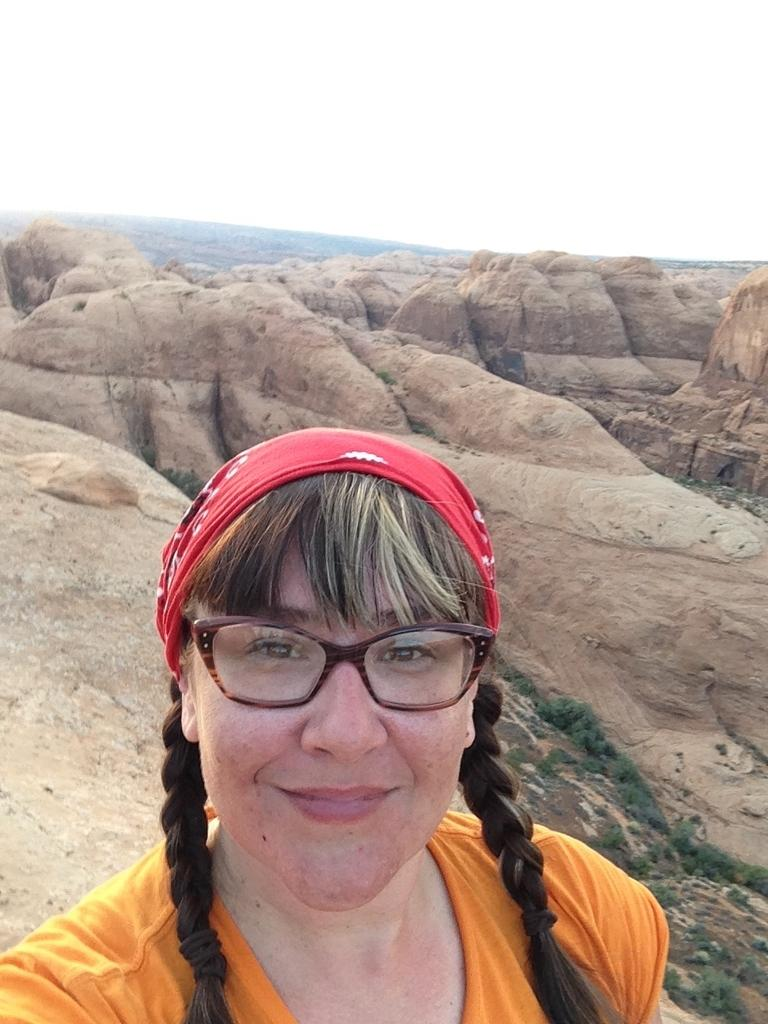Who is present in the image? There is a woman in the image. What is the woman wearing in the image? The woman is wearing spectacles in the image. What type of natural elements can be seen in the image? Rocks are visible in the image. What is visible in the background of the image? The sky is visible in the background of the image. How many babies are being taught by the woman in the image? There are no babies present in the image, and the woman is not teaching anyone. Where is the drawer located in the image? There is no drawer present in the image. 